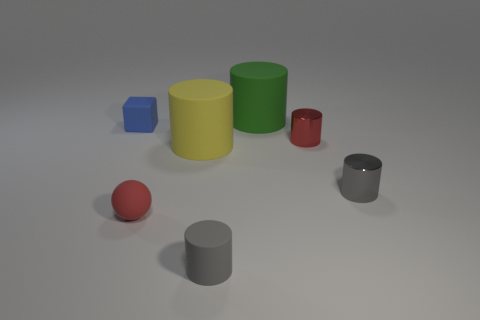Are there the same number of small gray things to the left of the blue matte thing and small blue things?
Offer a very short reply. No. What number of blue matte cubes are in front of the big rubber cylinder to the left of the cylinder in front of the small red ball?
Your answer should be very brief. 0. Is there any other thing that is the same size as the blue block?
Your response must be concise. Yes. There is a red shiny cylinder; does it have the same size as the rubber cylinder that is behind the yellow cylinder?
Your response must be concise. No. What number of big matte blocks are there?
Give a very brief answer. 0. Does the sphere on the left side of the yellow matte cylinder have the same size as the rubber thing that is behind the tiny blue cube?
Your answer should be very brief. No. What color is the tiny matte thing that is the same shape as the small gray metallic object?
Provide a short and direct response. Gray. Is the shape of the small red shiny object the same as the small blue matte object?
Offer a terse response. No. What is the size of the yellow matte thing that is the same shape as the small gray metal object?
Offer a very short reply. Large. What number of red spheres are the same material as the big green cylinder?
Provide a succinct answer. 1. 